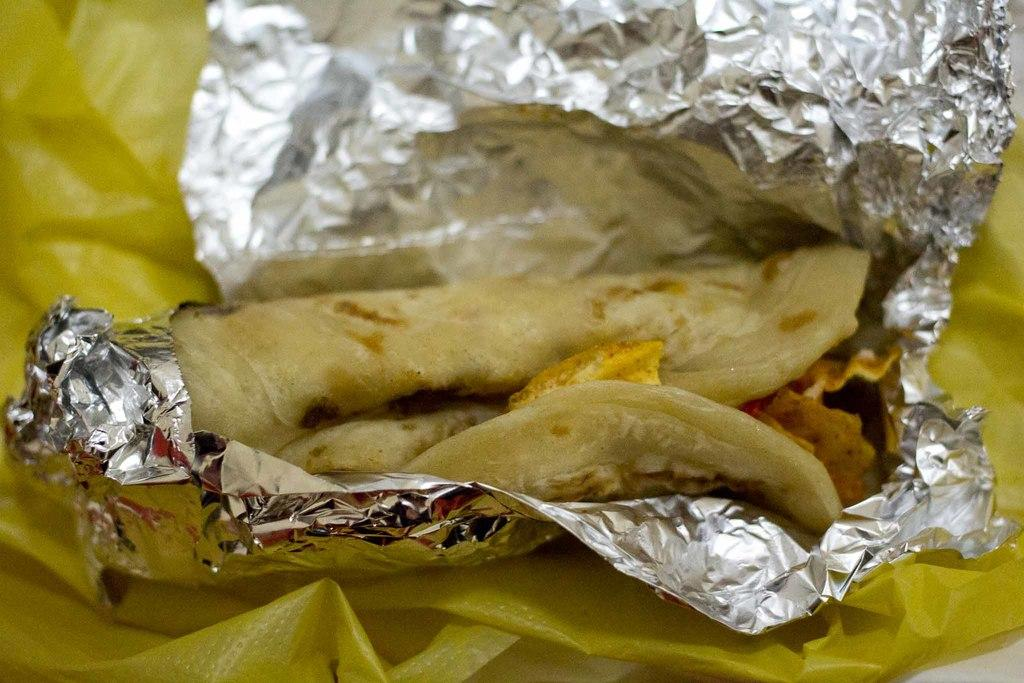What type of food is visible in the image? There is a chapati in the image. How is the chapati wrapped in the image? The chapati is rolled in a silver foil. What color is the cover at the bottom of the image? There is a yellow color cover at the bottom of the image. What type of beast can be seen roaming the streets in the image? There is no beast or street present in the image; it features a chapati wrapped in silver foil and a yellow color cover at the bottom. 